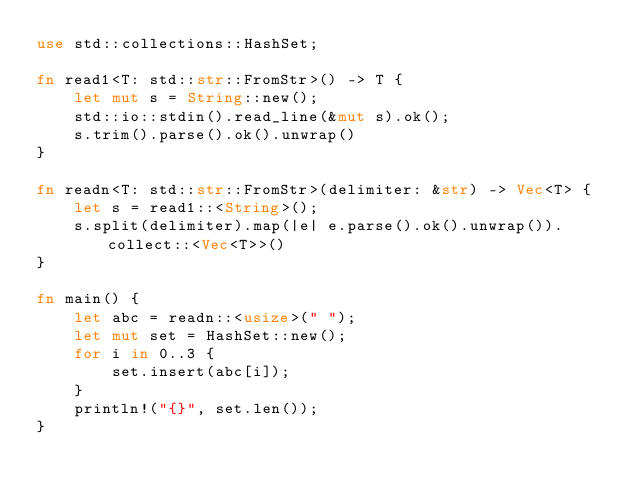<code> <loc_0><loc_0><loc_500><loc_500><_Rust_>use std::collections::HashSet;

fn read1<T: std::str::FromStr>() -> T {
    let mut s = String::new();
    std::io::stdin().read_line(&mut s).ok();
    s.trim().parse().ok().unwrap()
}

fn readn<T: std::str::FromStr>(delimiter: &str) -> Vec<T> {
    let s = read1::<String>();
    s.split(delimiter).map(|e| e.parse().ok().unwrap()).collect::<Vec<T>>()
}

fn main() {
    let abc = readn::<usize>(" ");
    let mut set = HashSet::new();
    for i in 0..3 {
        set.insert(abc[i]);
    }
    println!("{}", set.len());
}</code> 